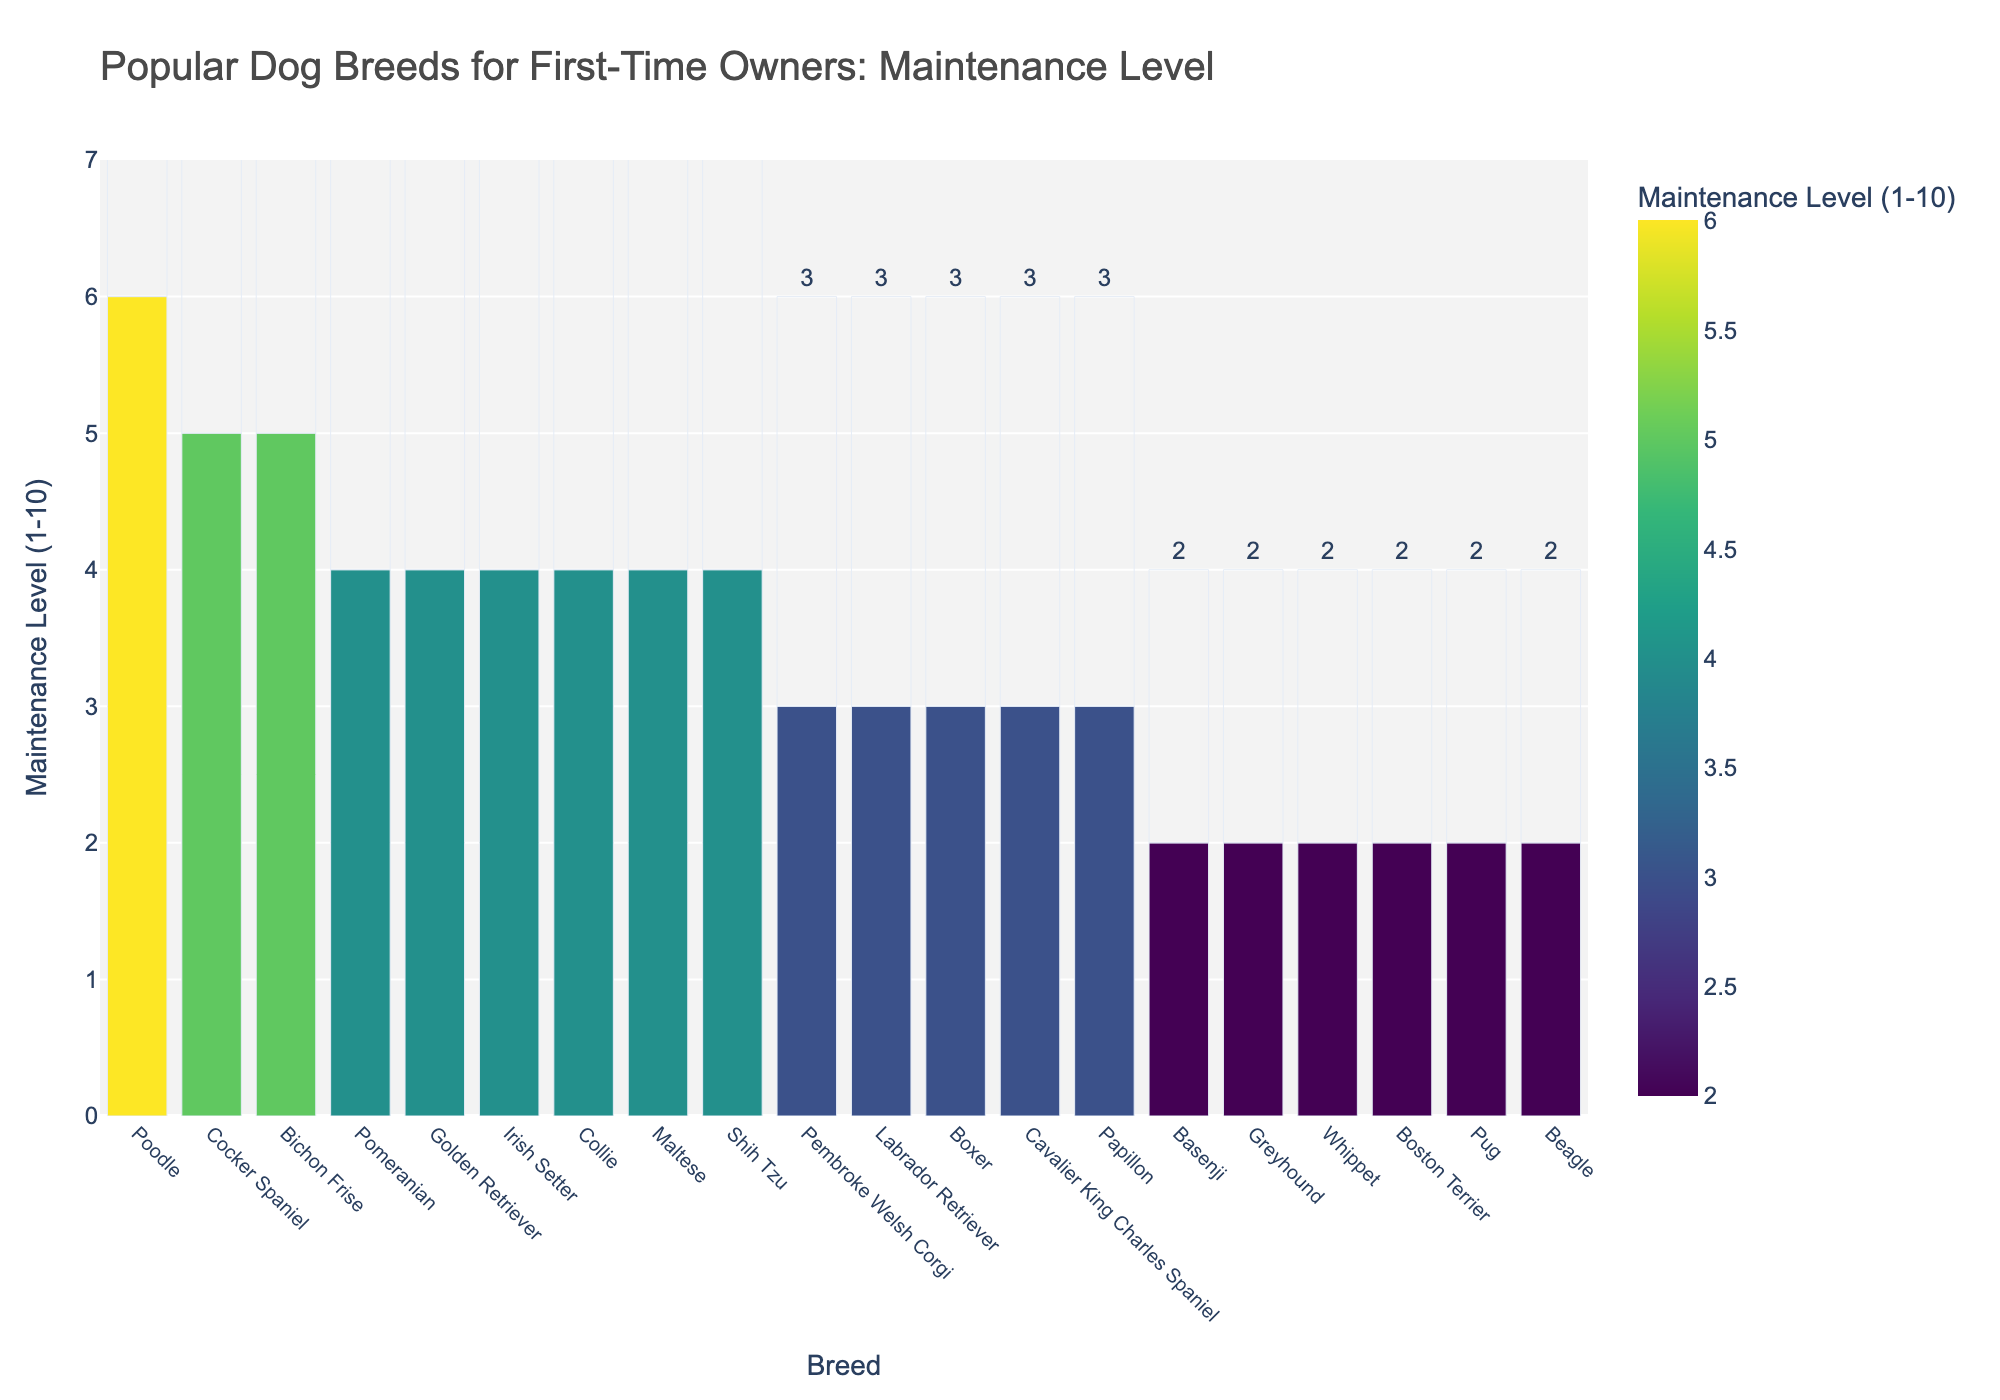What breed has the highest maintenance level? The bar associated with "Poodle" is the tallest, indicating it has the highest maintenance level of 6.
Answer: Poodle Which breeds have a maintenance level of 2? The bars at the height level of 2 represent Beagle, Pug, Greyhound, Basenji, Whippet, and Boston Terrier.
Answer: Beagle, Pug, Greyhound, Basenji, Whippet, Boston Terrier What is the average maintenance level of all the dog breeds? Sum all the maintenance levels (3+4+6+2+2+3+5+3+2+4+3+2+4+3+2+2+5+4+4+4 = 68) and divide by the number of breeds (20). The average maintenance level is 68/20 = 3.4
Answer: 3.4 Compare the maintenance level of Golden Retriever and Shih Tzu. Which one is higher and by how much? Golden Retriever has a maintenance level of 4, and Shih Tzu also has a maintenance level of 4. The difference in maintenance level is 0, indicating they have the same maintenance level.
Answer: Same, 0 What is the difference between the highest and lowest maintenance levels? The highest maintenance level is 6 (Poodle), and the lowest is 2 (multiple breeds). The difference is 6 - 2 = 4.
Answer: 4 Which breeds have a higher maintenance level than Labrador Retriever? Labrador Retriever has a maintenance level of 3. The breeds with a maintenance level higher than 3 are Golden Retriever (4), Poodle (6), Bichon Frise (5), Shih Tzu (4), Maltese (4), Cocker Spaniel (5), Collie (4), Irish Setter (4), and Pomeranian (4).
Answer: Golden Retriever, Poodle, Bichon Frise, Shih Tzu, Maltese, Cocker Spaniel, Collie, Irish Setter, Pomeranian Identify the breed(s) with a maintenance level of 5. The bars at the height level of 5 represent Bichon Frise and Cocker Spaniel.
Answer: Bichon Frise, Cocker Spaniel Which breed has a maintenance level that is in the middle of the given range (1-10) and how many breeds share this level? A maintenance level in the middle of the range 1-10 is 5. The breeds with a maintenance level of 5 are Bichon Frise and Cocker Spaniel, thus 2 breeds share this level.
Answer: Bichon Frise, Cocker Spaniel, 2 How many breeds have a maintenance level of 4? Count the bars at the height level of 4, which are Golden Retriever, Shih Tzu, Maltese, Collie, Irish Setter, and Pomeranian.
Answer: 6 Compare the number of breeds with maintenance levels of 2 and 3. Which group has more breeds, and by how many? The breeds with a maintenance level of 2 are Beagle, Pug, Greyhound, Basenji, Whippet, and Boston Terrier (6 breeds). The breeds with a maintenance level of 3 are Labrador Retriever, Cavalier King Charles Spaniel, Boxer, Papillon, and Pembroke Welsh Corgi (5 breeds). 6 - 5 = 1, so more breeds have a maintenance level of 2.
Answer: Maintenance level 2, by 1 